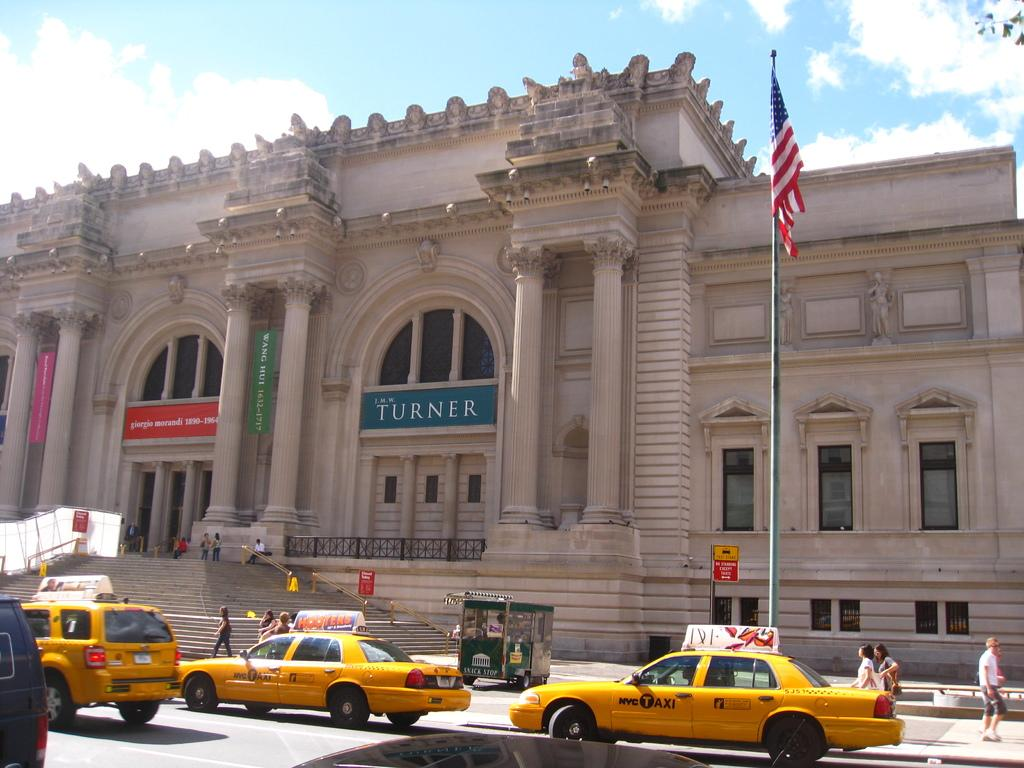<image>
Give a short and clear explanation of the subsequent image. A historic looking building with several colored banners, the blue banner has the name J.M.W. Turner 